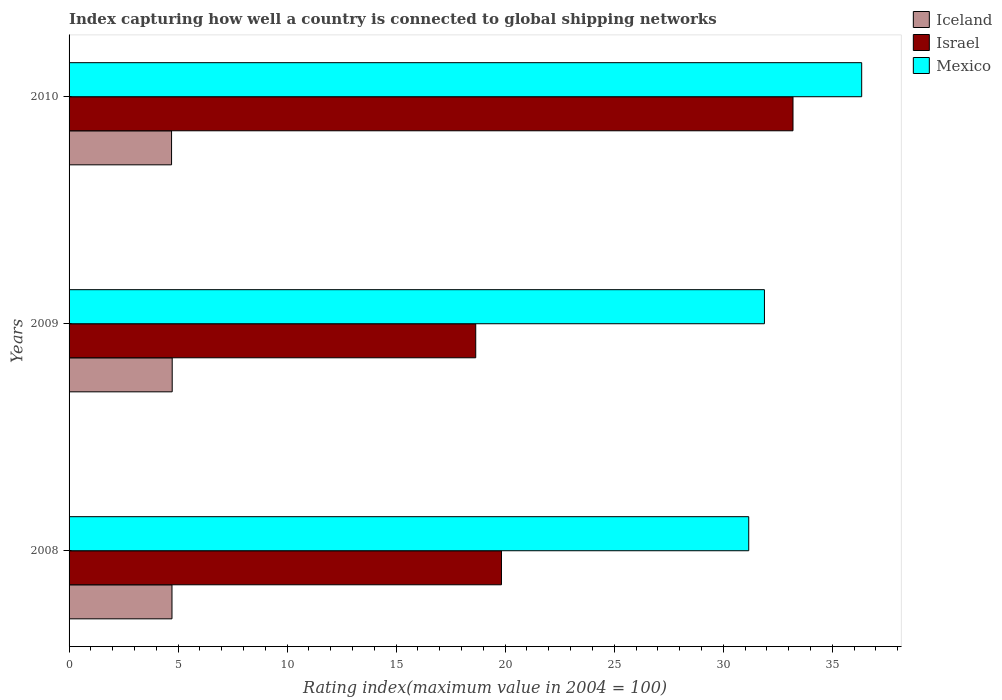Are the number of bars per tick equal to the number of legend labels?
Provide a succinct answer. Yes. Are the number of bars on each tick of the Y-axis equal?
Offer a terse response. Yes. How many bars are there on the 2nd tick from the top?
Give a very brief answer. 3. How many bars are there on the 3rd tick from the bottom?
Your answer should be very brief. 3. What is the rating index in Mexico in 2008?
Your answer should be very brief. 31.17. Across all years, what is the maximum rating index in Israel?
Make the answer very short. 33.2. In which year was the rating index in Israel maximum?
Offer a terse response. 2010. In which year was the rating index in Israel minimum?
Ensure brevity in your answer.  2009. What is the total rating index in Mexico in the graph?
Make the answer very short. 99.41. What is the difference between the rating index in Israel in 2008 and that in 2010?
Make the answer very short. -13.37. What is the difference between the rating index in Mexico in 2010 and the rating index in Israel in 2008?
Your answer should be very brief. 16.52. What is the average rating index in Iceland per year?
Offer a very short reply. 4.72. In the year 2009, what is the difference between the rating index in Iceland and rating index in Mexico?
Keep it short and to the point. -27.16. In how many years, is the rating index in Iceland greater than 22 ?
Provide a short and direct response. 0. What is the ratio of the rating index in Iceland in 2008 to that in 2010?
Offer a terse response. 1. What is the difference between the highest and the second highest rating index in Mexico?
Make the answer very short. 4.46. What is the difference between the highest and the lowest rating index in Israel?
Offer a terse response. 14.55. In how many years, is the rating index in Iceland greater than the average rating index in Iceland taken over all years?
Your answer should be compact. 2. What does the 2nd bar from the top in 2009 represents?
Give a very brief answer. Israel. What does the 3rd bar from the bottom in 2008 represents?
Your response must be concise. Mexico. Is it the case that in every year, the sum of the rating index in Mexico and rating index in Iceland is greater than the rating index in Israel?
Give a very brief answer. Yes. Are all the bars in the graph horizontal?
Your response must be concise. Yes. How many years are there in the graph?
Your answer should be compact. 3. What is the difference between two consecutive major ticks on the X-axis?
Make the answer very short. 5. Are the values on the major ticks of X-axis written in scientific E-notation?
Provide a succinct answer. No. Does the graph contain any zero values?
Provide a short and direct response. No. Does the graph contain grids?
Ensure brevity in your answer.  No. Where does the legend appear in the graph?
Your answer should be very brief. Top right. How many legend labels are there?
Give a very brief answer. 3. How are the legend labels stacked?
Give a very brief answer. Vertical. What is the title of the graph?
Your answer should be very brief. Index capturing how well a country is connected to global shipping networks. What is the label or title of the X-axis?
Offer a very short reply. Rating index(maximum value in 2004 = 100). What is the Rating index(maximum value in 2004 = 100) of Iceland in 2008?
Give a very brief answer. 4.72. What is the Rating index(maximum value in 2004 = 100) in Israel in 2008?
Keep it short and to the point. 19.83. What is the Rating index(maximum value in 2004 = 100) in Mexico in 2008?
Offer a very short reply. 31.17. What is the Rating index(maximum value in 2004 = 100) of Iceland in 2009?
Ensure brevity in your answer.  4.73. What is the Rating index(maximum value in 2004 = 100) of Israel in 2009?
Provide a short and direct response. 18.65. What is the Rating index(maximum value in 2004 = 100) of Mexico in 2009?
Offer a terse response. 31.89. What is the Rating index(maximum value in 2004 = 100) in Iceland in 2010?
Your answer should be compact. 4.7. What is the Rating index(maximum value in 2004 = 100) in Israel in 2010?
Offer a terse response. 33.2. What is the Rating index(maximum value in 2004 = 100) in Mexico in 2010?
Make the answer very short. 36.35. Across all years, what is the maximum Rating index(maximum value in 2004 = 100) of Iceland?
Your answer should be compact. 4.73. Across all years, what is the maximum Rating index(maximum value in 2004 = 100) in Israel?
Provide a short and direct response. 33.2. Across all years, what is the maximum Rating index(maximum value in 2004 = 100) of Mexico?
Provide a succinct answer. 36.35. Across all years, what is the minimum Rating index(maximum value in 2004 = 100) in Israel?
Your response must be concise. 18.65. Across all years, what is the minimum Rating index(maximum value in 2004 = 100) in Mexico?
Offer a terse response. 31.17. What is the total Rating index(maximum value in 2004 = 100) of Iceland in the graph?
Make the answer very short. 14.15. What is the total Rating index(maximum value in 2004 = 100) in Israel in the graph?
Provide a succinct answer. 71.68. What is the total Rating index(maximum value in 2004 = 100) in Mexico in the graph?
Offer a terse response. 99.41. What is the difference between the Rating index(maximum value in 2004 = 100) of Iceland in 2008 and that in 2009?
Your response must be concise. -0.01. What is the difference between the Rating index(maximum value in 2004 = 100) in Israel in 2008 and that in 2009?
Provide a short and direct response. 1.18. What is the difference between the Rating index(maximum value in 2004 = 100) of Mexico in 2008 and that in 2009?
Your response must be concise. -0.72. What is the difference between the Rating index(maximum value in 2004 = 100) in Iceland in 2008 and that in 2010?
Provide a short and direct response. 0.02. What is the difference between the Rating index(maximum value in 2004 = 100) in Israel in 2008 and that in 2010?
Your answer should be compact. -13.37. What is the difference between the Rating index(maximum value in 2004 = 100) of Mexico in 2008 and that in 2010?
Your answer should be compact. -5.18. What is the difference between the Rating index(maximum value in 2004 = 100) in Israel in 2009 and that in 2010?
Offer a terse response. -14.55. What is the difference between the Rating index(maximum value in 2004 = 100) in Mexico in 2009 and that in 2010?
Ensure brevity in your answer.  -4.46. What is the difference between the Rating index(maximum value in 2004 = 100) in Iceland in 2008 and the Rating index(maximum value in 2004 = 100) in Israel in 2009?
Your answer should be compact. -13.93. What is the difference between the Rating index(maximum value in 2004 = 100) of Iceland in 2008 and the Rating index(maximum value in 2004 = 100) of Mexico in 2009?
Provide a succinct answer. -27.17. What is the difference between the Rating index(maximum value in 2004 = 100) of Israel in 2008 and the Rating index(maximum value in 2004 = 100) of Mexico in 2009?
Your response must be concise. -12.06. What is the difference between the Rating index(maximum value in 2004 = 100) in Iceland in 2008 and the Rating index(maximum value in 2004 = 100) in Israel in 2010?
Provide a succinct answer. -28.48. What is the difference between the Rating index(maximum value in 2004 = 100) in Iceland in 2008 and the Rating index(maximum value in 2004 = 100) in Mexico in 2010?
Ensure brevity in your answer.  -31.63. What is the difference between the Rating index(maximum value in 2004 = 100) in Israel in 2008 and the Rating index(maximum value in 2004 = 100) in Mexico in 2010?
Your answer should be compact. -16.52. What is the difference between the Rating index(maximum value in 2004 = 100) in Iceland in 2009 and the Rating index(maximum value in 2004 = 100) in Israel in 2010?
Your answer should be very brief. -28.47. What is the difference between the Rating index(maximum value in 2004 = 100) of Iceland in 2009 and the Rating index(maximum value in 2004 = 100) of Mexico in 2010?
Offer a very short reply. -31.62. What is the difference between the Rating index(maximum value in 2004 = 100) in Israel in 2009 and the Rating index(maximum value in 2004 = 100) in Mexico in 2010?
Provide a succinct answer. -17.7. What is the average Rating index(maximum value in 2004 = 100) in Iceland per year?
Provide a short and direct response. 4.72. What is the average Rating index(maximum value in 2004 = 100) of Israel per year?
Your response must be concise. 23.89. What is the average Rating index(maximum value in 2004 = 100) of Mexico per year?
Provide a short and direct response. 33.14. In the year 2008, what is the difference between the Rating index(maximum value in 2004 = 100) of Iceland and Rating index(maximum value in 2004 = 100) of Israel?
Give a very brief answer. -15.11. In the year 2008, what is the difference between the Rating index(maximum value in 2004 = 100) in Iceland and Rating index(maximum value in 2004 = 100) in Mexico?
Provide a short and direct response. -26.45. In the year 2008, what is the difference between the Rating index(maximum value in 2004 = 100) of Israel and Rating index(maximum value in 2004 = 100) of Mexico?
Ensure brevity in your answer.  -11.34. In the year 2009, what is the difference between the Rating index(maximum value in 2004 = 100) in Iceland and Rating index(maximum value in 2004 = 100) in Israel?
Give a very brief answer. -13.92. In the year 2009, what is the difference between the Rating index(maximum value in 2004 = 100) of Iceland and Rating index(maximum value in 2004 = 100) of Mexico?
Provide a short and direct response. -27.16. In the year 2009, what is the difference between the Rating index(maximum value in 2004 = 100) of Israel and Rating index(maximum value in 2004 = 100) of Mexico?
Provide a short and direct response. -13.24. In the year 2010, what is the difference between the Rating index(maximum value in 2004 = 100) in Iceland and Rating index(maximum value in 2004 = 100) in Israel?
Your answer should be compact. -28.5. In the year 2010, what is the difference between the Rating index(maximum value in 2004 = 100) of Iceland and Rating index(maximum value in 2004 = 100) of Mexico?
Your response must be concise. -31.65. In the year 2010, what is the difference between the Rating index(maximum value in 2004 = 100) of Israel and Rating index(maximum value in 2004 = 100) of Mexico?
Offer a very short reply. -3.15. What is the ratio of the Rating index(maximum value in 2004 = 100) of Iceland in 2008 to that in 2009?
Ensure brevity in your answer.  1. What is the ratio of the Rating index(maximum value in 2004 = 100) of Israel in 2008 to that in 2009?
Give a very brief answer. 1.06. What is the ratio of the Rating index(maximum value in 2004 = 100) of Mexico in 2008 to that in 2009?
Offer a very short reply. 0.98. What is the ratio of the Rating index(maximum value in 2004 = 100) in Israel in 2008 to that in 2010?
Your answer should be compact. 0.6. What is the ratio of the Rating index(maximum value in 2004 = 100) in Mexico in 2008 to that in 2010?
Your answer should be compact. 0.86. What is the ratio of the Rating index(maximum value in 2004 = 100) of Iceland in 2009 to that in 2010?
Your response must be concise. 1.01. What is the ratio of the Rating index(maximum value in 2004 = 100) in Israel in 2009 to that in 2010?
Provide a succinct answer. 0.56. What is the ratio of the Rating index(maximum value in 2004 = 100) of Mexico in 2009 to that in 2010?
Make the answer very short. 0.88. What is the difference between the highest and the second highest Rating index(maximum value in 2004 = 100) of Iceland?
Ensure brevity in your answer.  0.01. What is the difference between the highest and the second highest Rating index(maximum value in 2004 = 100) of Israel?
Provide a succinct answer. 13.37. What is the difference between the highest and the second highest Rating index(maximum value in 2004 = 100) in Mexico?
Give a very brief answer. 4.46. What is the difference between the highest and the lowest Rating index(maximum value in 2004 = 100) of Iceland?
Your response must be concise. 0.03. What is the difference between the highest and the lowest Rating index(maximum value in 2004 = 100) in Israel?
Provide a short and direct response. 14.55. What is the difference between the highest and the lowest Rating index(maximum value in 2004 = 100) of Mexico?
Offer a very short reply. 5.18. 